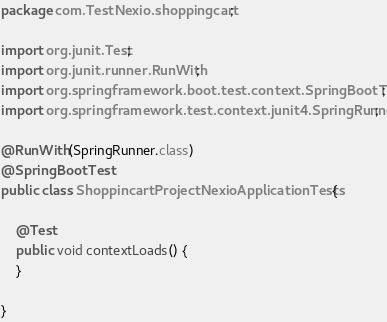Convert code to text. <code><loc_0><loc_0><loc_500><loc_500><_Java_>package com.TestNexio.shoppingcart;

import org.junit.Test;
import org.junit.runner.RunWith;
import org.springframework.boot.test.context.SpringBootTest;
import org.springframework.test.context.junit4.SpringRunner;

@RunWith(SpringRunner.class)
@SpringBootTest
public class ShoppincartProjectNexioApplicationTests {

	@Test
	public void contextLoads() {
	}

}
</code> 